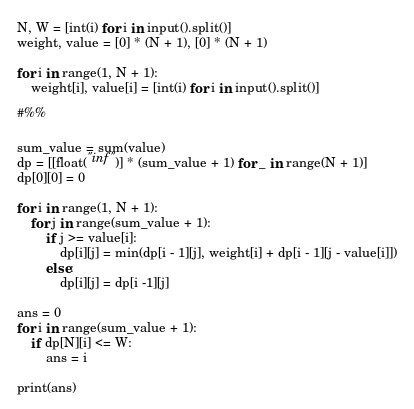Convert code to text. <code><loc_0><loc_0><loc_500><loc_500><_Python_>N, W = [int(i) for i in input().split()]
weight, value = [0] * (N + 1), [0] * (N + 1)

for i in range(1, N + 1):
    weight[i], value[i] = [int(i) for i in input().split()]

#%%

sum_value = sum(value)
dp = [[float("inf")] * (sum_value + 1) for _ in range(N + 1)]
dp[0][0] = 0

for i in range(1, N + 1):
    for j in range(sum_value + 1):
        if j >= value[i]:
            dp[i][j] = min(dp[i - 1][j], weight[i] + dp[i - 1][j - value[i]])
        else:
            dp[i][j] = dp[i -1][j]
        
ans = 0
for i in range(sum_value + 1):
    if dp[N][i] <= W:
        ans = i

print(ans)</code> 